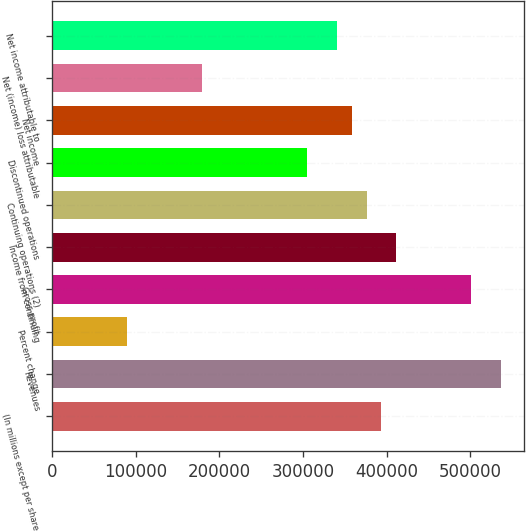Convert chart to OTSL. <chart><loc_0><loc_0><loc_500><loc_500><bar_chart><fcel>(In millions except per share<fcel>Revenues<fcel>Percent change<fcel>Gross profit<fcel>Income from continuing<fcel>Continuing operations (2)<fcel>Discontinued operations<fcel>Net income<fcel>Net (income) loss attributable<fcel>Net income attributable to<nl><fcel>393898<fcel>537133<fcel>89523<fcel>501324<fcel>411802<fcel>375993<fcel>304376<fcel>358089<fcel>179045<fcel>340185<nl></chart> 